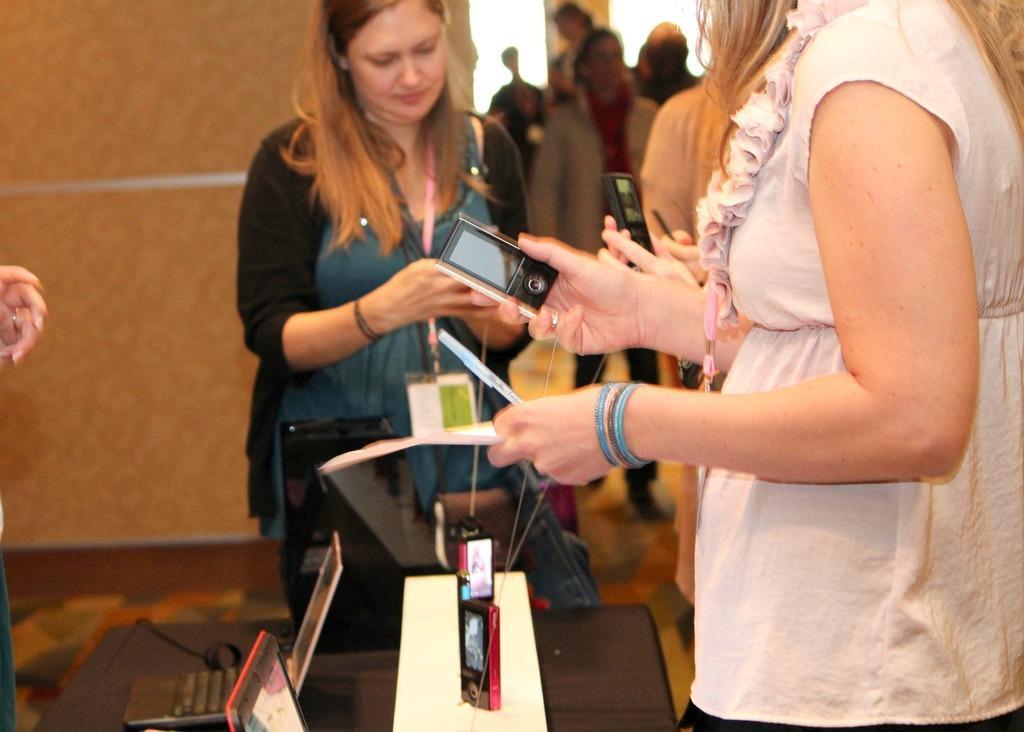Can you describe this image briefly? In this image there are few women who are holding the Ipod in their hand. There is a table in front of them on which there are laptops on it. At the background there is a wall. 